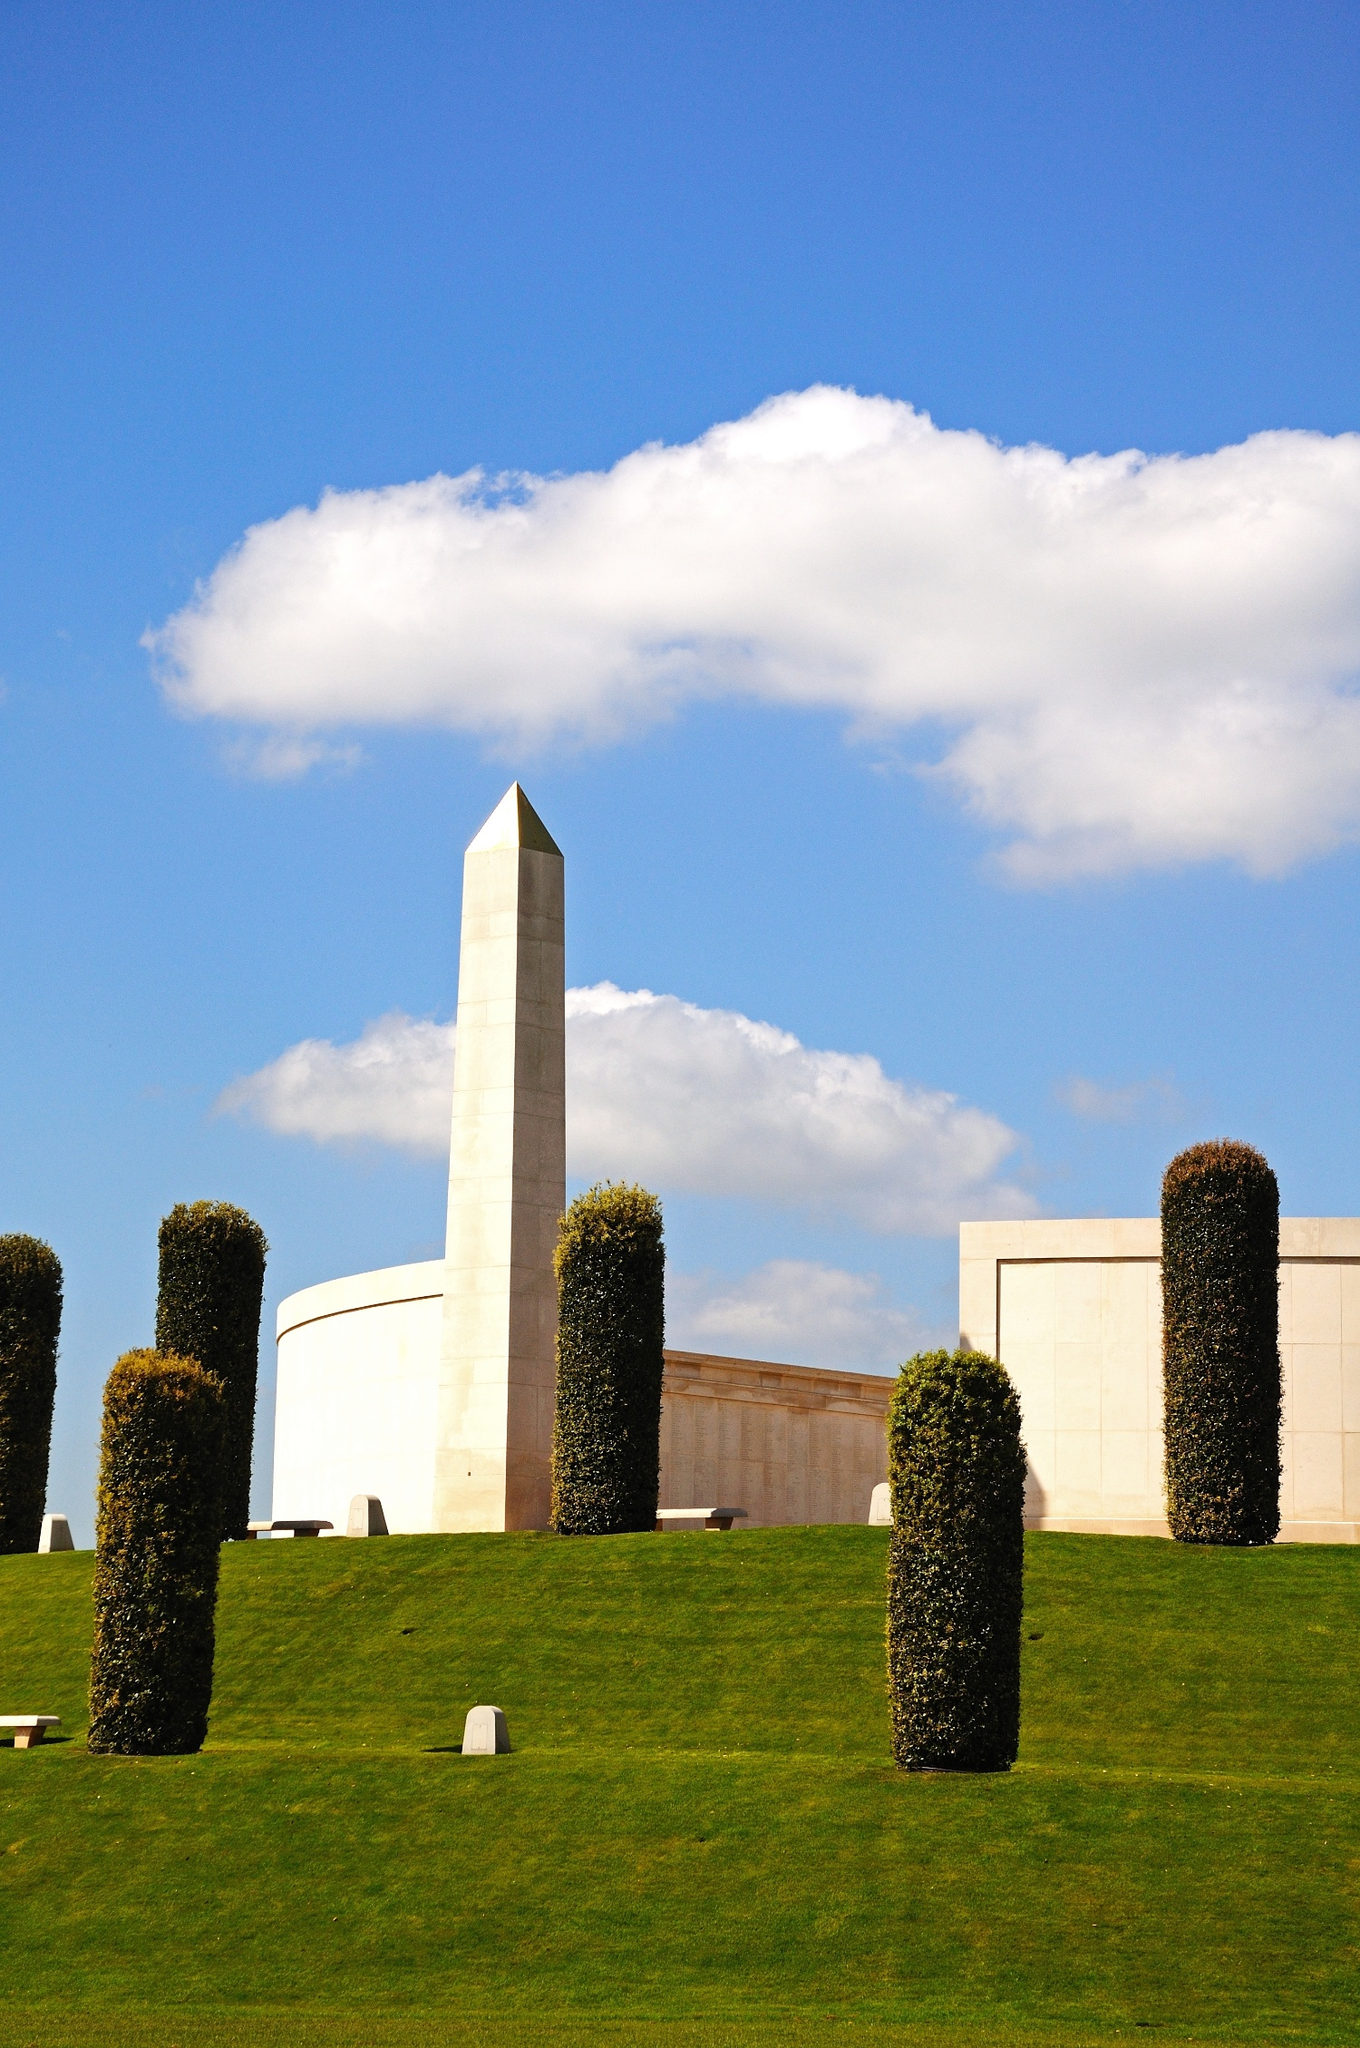Can you paint a vivid scenario of a soldier's family visiting this memorial? A family of four approaches the obelisk, their footsteps soft on the lush green grass. The mother holds a bouquet of poppies, the red hue vivid against the white stone. She kneels to place them at the base, her fingers gently brushing the engraving. The father stands tall, his uniform adorned with medals, eyes misting as he remembers his comrades. Their children, a boy and a girl, clutch small tokens—a toy soldier and a drawing—gifts for a father they only know through stories. As they stand together, the sun breaks through the clouds, casting a warm glow on the obelisk. The grandfather joins them, sharing tales of bravery and duty. They listen, the legacy of service etched into their hearts, bound by love and memory in this sacred place. 